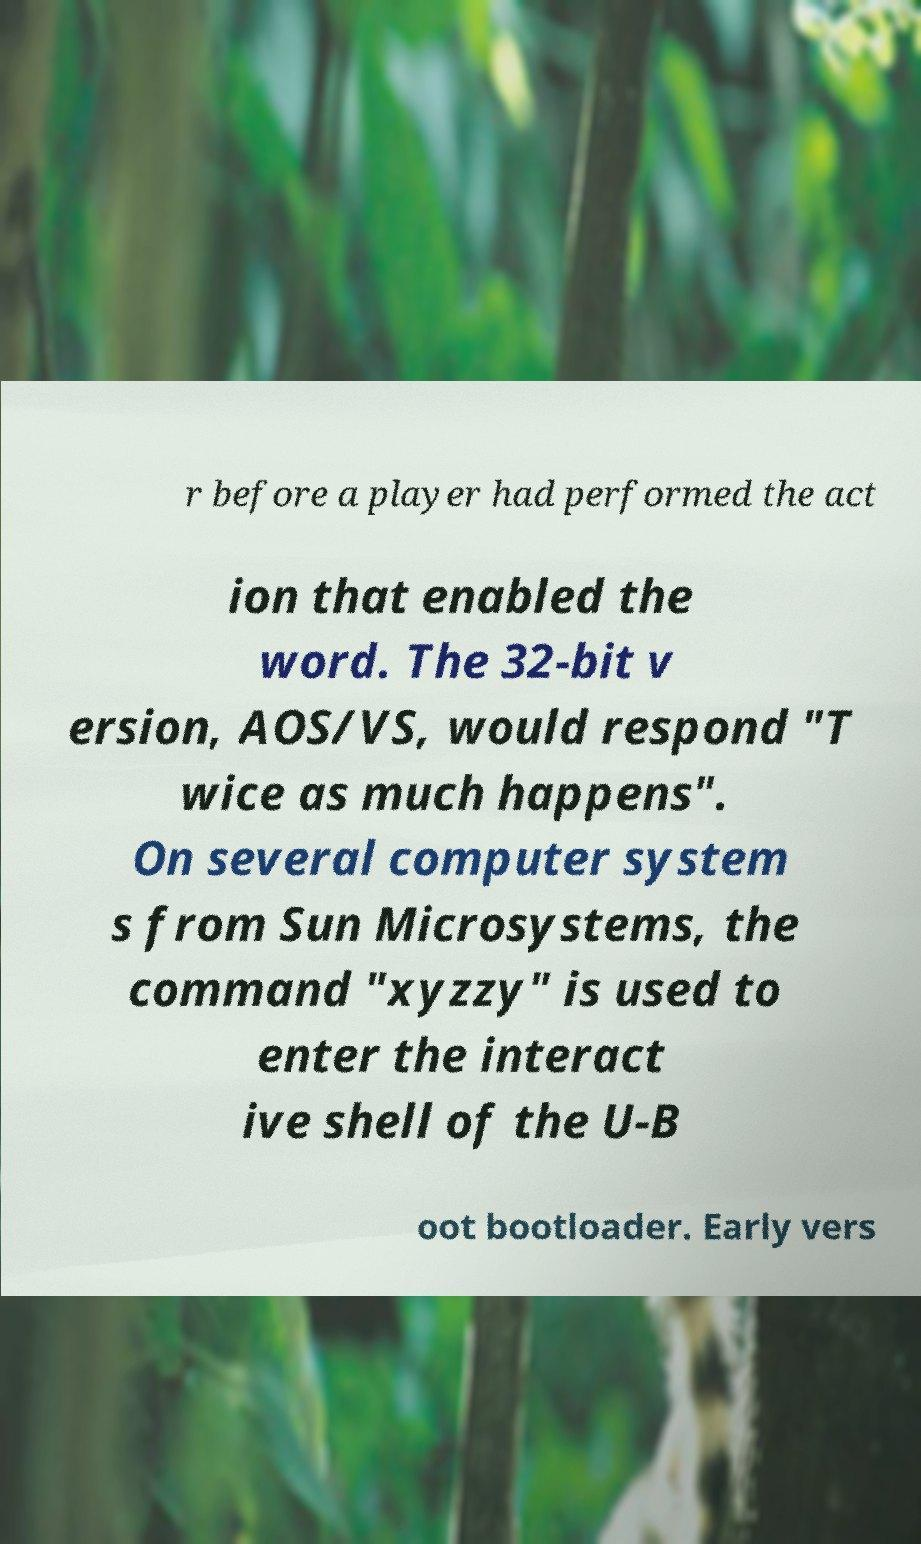Please identify and transcribe the text found in this image. r before a player had performed the act ion that enabled the word. The 32-bit v ersion, AOS/VS, would respond "T wice as much happens". On several computer system s from Sun Microsystems, the command "xyzzy" is used to enter the interact ive shell of the U-B oot bootloader. Early vers 